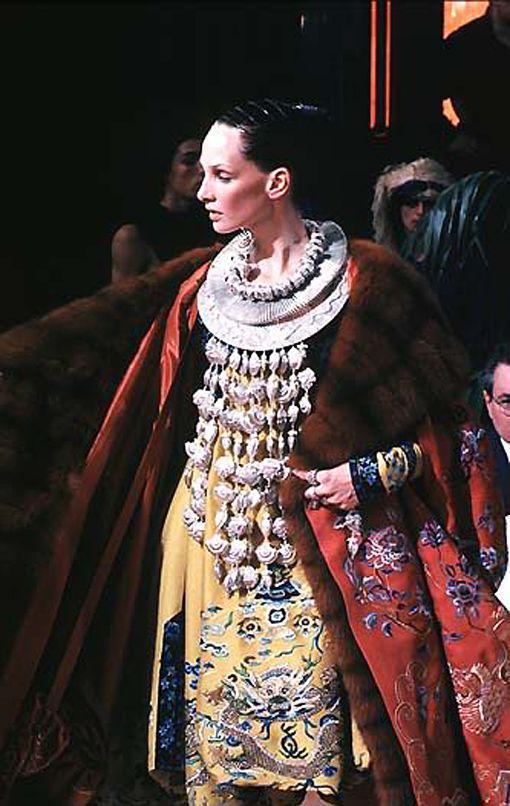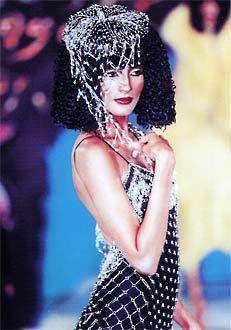The first image is the image on the left, the second image is the image on the right. Given the left and right images, does the statement "At least one front view and one back view of fashions are shown by models." hold true? Answer yes or no. No. The first image is the image on the left, the second image is the image on the right. Assess this claim about the two images: "You cannot see the face of at least one of the models.". Correct or not? Answer yes or no. No. 